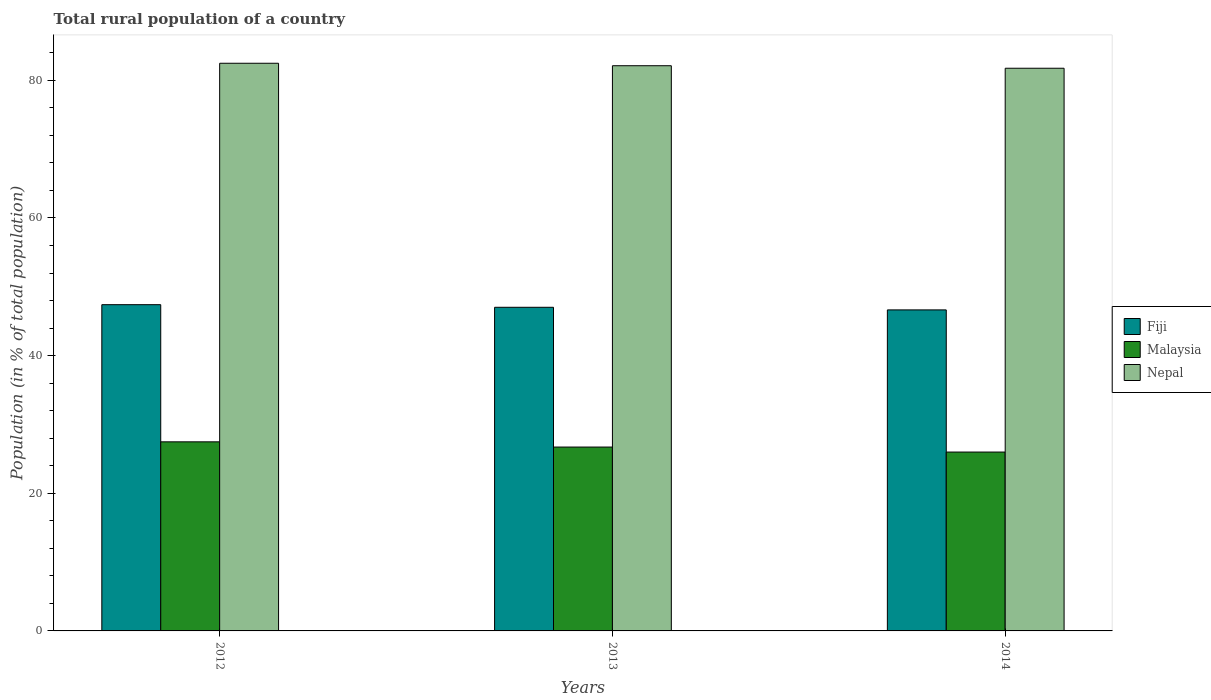How many different coloured bars are there?
Keep it short and to the point. 3. How many groups of bars are there?
Provide a short and direct response. 3. Are the number of bars per tick equal to the number of legend labels?
Your answer should be compact. Yes. How many bars are there on the 3rd tick from the left?
Offer a very short reply. 3. What is the label of the 3rd group of bars from the left?
Ensure brevity in your answer.  2014. What is the rural population in Malaysia in 2012?
Your answer should be compact. 27.47. Across all years, what is the maximum rural population in Nepal?
Offer a very short reply. 82.48. Across all years, what is the minimum rural population in Nepal?
Make the answer very short. 81.76. What is the total rural population in Nepal in the graph?
Ensure brevity in your answer.  246.36. What is the difference between the rural population in Fiji in 2012 and that in 2014?
Your answer should be very brief. 0.76. What is the difference between the rural population in Nepal in 2014 and the rural population in Malaysia in 2012?
Offer a terse response. 54.28. What is the average rural population in Nepal per year?
Give a very brief answer. 82.12. In the year 2012, what is the difference between the rural population in Malaysia and rural population in Fiji?
Offer a terse response. -19.93. In how many years, is the rural population in Malaysia greater than 60 %?
Your response must be concise. 0. What is the ratio of the rural population in Malaysia in 2012 to that in 2014?
Offer a very short reply. 1.06. Is the rural population in Nepal in 2012 less than that in 2014?
Offer a very short reply. No. Is the difference between the rural population in Malaysia in 2012 and 2013 greater than the difference between the rural population in Fiji in 2012 and 2013?
Your answer should be compact. Yes. What is the difference between the highest and the second highest rural population in Fiji?
Ensure brevity in your answer.  0.38. What is the difference between the highest and the lowest rural population in Fiji?
Ensure brevity in your answer.  0.76. What does the 3rd bar from the left in 2014 represents?
Provide a succinct answer. Nepal. What does the 1st bar from the right in 2012 represents?
Provide a short and direct response. Nepal. Is it the case that in every year, the sum of the rural population in Fiji and rural population in Malaysia is greater than the rural population in Nepal?
Your answer should be compact. No. How many bars are there?
Offer a very short reply. 9. How many years are there in the graph?
Make the answer very short. 3. What is the difference between two consecutive major ticks on the Y-axis?
Offer a terse response. 20. Does the graph contain any zero values?
Give a very brief answer. No. Where does the legend appear in the graph?
Your answer should be compact. Center right. What is the title of the graph?
Your response must be concise. Total rural population of a country. Does "Tuvalu" appear as one of the legend labels in the graph?
Your response must be concise. No. What is the label or title of the Y-axis?
Offer a terse response. Population (in % of total population). What is the Population (in % of total population) in Fiji in 2012?
Make the answer very short. 47.4. What is the Population (in % of total population) in Malaysia in 2012?
Your answer should be compact. 27.47. What is the Population (in % of total population) of Nepal in 2012?
Keep it short and to the point. 82.48. What is the Population (in % of total population) of Fiji in 2013?
Give a very brief answer. 47.02. What is the Population (in % of total population) of Malaysia in 2013?
Your answer should be very brief. 26.72. What is the Population (in % of total population) in Nepal in 2013?
Offer a very short reply. 82.12. What is the Population (in % of total population) of Fiji in 2014?
Your answer should be compact. 46.65. What is the Population (in % of total population) of Malaysia in 2014?
Your answer should be compact. 25.99. What is the Population (in % of total population) in Nepal in 2014?
Your response must be concise. 81.76. Across all years, what is the maximum Population (in % of total population) of Fiji?
Your answer should be very brief. 47.4. Across all years, what is the maximum Population (in % of total population) of Malaysia?
Offer a very short reply. 27.47. Across all years, what is the maximum Population (in % of total population) in Nepal?
Provide a succinct answer. 82.48. Across all years, what is the minimum Population (in % of total population) in Fiji?
Offer a very short reply. 46.65. Across all years, what is the minimum Population (in % of total population) of Malaysia?
Your response must be concise. 25.99. Across all years, what is the minimum Population (in % of total population) in Nepal?
Ensure brevity in your answer.  81.76. What is the total Population (in % of total population) of Fiji in the graph?
Provide a succinct answer. 141.07. What is the total Population (in % of total population) of Malaysia in the graph?
Provide a short and direct response. 80.18. What is the total Population (in % of total population) in Nepal in the graph?
Ensure brevity in your answer.  246.36. What is the difference between the Population (in % of total population) in Fiji in 2012 and that in 2013?
Your response must be concise. 0.38. What is the difference between the Population (in % of total population) of Malaysia in 2012 and that in 2013?
Offer a very short reply. 0.76. What is the difference between the Population (in % of total population) of Nepal in 2012 and that in 2013?
Offer a very short reply. 0.36. What is the difference between the Population (in % of total population) in Fiji in 2012 and that in 2014?
Offer a very short reply. 0.76. What is the difference between the Population (in % of total population) in Malaysia in 2012 and that in 2014?
Offer a very short reply. 1.48. What is the difference between the Population (in % of total population) of Nepal in 2012 and that in 2014?
Give a very brief answer. 0.72. What is the difference between the Population (in % of total population) of Fiji in 2013 and that in 2014?
Provide a short and direct response. 0.38. What is the difference between the Population (in % of total population) of Malaysia in 2013 and that in 2014?
Your response must be concise. 0.73. What is the difference between the Population (in % of total population) in Nepal in 2013 and that in 2014?
Provide a short and direct response. 0.37. What is the difference between the Population (in % of total population) in Fiji in 2012 and the Population (in % of total population) in Malaysia in 2013?
Your answer should be compact. 20.69. What is the difference between the Population (in % of total population) of Fiji in 2012 and the Population (in % of total population) of Nepal in 2013?
Provide a succinct answer. -34.72. What is the difference between the Population (in % of total population) of Malaysia in 2012 and the Population (in % of total population) of Nepal in 2013?
Your answer should be compact. -54.65. What is the difference between the Population (in % of total population) in Fiji in 2012 and the Population (in % of total population) in Malaysia in 2014?
Make the answer very short. 21.41. What is the difference between the Population (in % of total population) of Fiji in 2012 and the Population (in % of total population) of Nepal in 2014?
Your response must be concise. -34.35. What is the difference between the Population (in % of total population) in Malaysia in 2012 and the Population (in % of total population) in Nepal in 2014?
Keep it short and to the point. -54.28. What is the difference between the Population (in % of total population) of Fiji in 2013 and the Population (in % of total population) of Malaysia in 2014?
Offer a terse response. 21.03. What is the difference between the Population (in % of total population) of Fiji in 2013 and the Population (in % of total population) of Nepal in 2014?
Ensure brevity in your answer.  -34.73. What is the difference between the Population (in % of total population) in Malaysia in 2013 and the Population (in % of total population) in Nepal in 2014?
Make the answer very short. -55.04. What is the average Population (in % of total population) of Fiji per year?
Offer a very short reply. 47.02. What is the average Population (in % of total population) of Malaysia per year?
Your response must be concise. 26.73. What is the average Population (in % of total population) of Nepal per year?
Your answer should be compact. 82.12. In the year 2012, what is the difference between the Population (in % of total population) of Fiji and Population (in % of total population) of Malaysia?
Your response must be concise. 19.93. In the year 2012, what is the difference between the Population (in % of total population) in Fiji and Population (in % of total population) in Nepal?
Offer a very short reply. -35.08. In the year 2012, what is the difference between the Population (in % of total population) in Malaysia and Population (in % of total population) in Nepal?
Your response must be concise. -55.01. In the year 2013, what is the difference between the Population (in % of total population) of Fiji and Population (in % of total population) of Malaysia?
Offer a terse response. 20.31. In the year 2013, what is the difference between the Population (in % of total population) of Fiji and Population (in % of total population) of Nepal?
Provide a short and direct response. -35.1. In the year 2013, what is the difference between the Population (in % of total population) of Malaysia and Population (in % of total population) of Nepal?
Provide a succinct answer. -55.41. In the year 2014, what is the difference between the Population (in % of total population) in Fiji and Population (in % of total population) in Malaysia?
Give a very brief answer. 20.66. In the year 2014, what is the difference between the Population (in % of total population) of Fiji and Population (in % of total population) of Nepal?
Provide a succinct answer. -35.11. In the year 2014, what is the difference between the Population (in % of total population) of Malaysia and Population (in % of total population) of Nepal?
Keep it short and to the point. -55.77. What is the ratio of the Population (in % of total population) of Malaysia in 2012 to that in 2013?
Provide a succinct answer. 1.03. What is the ratio of the Population (in % of total population) of Nepal in 2012 to that in 2013?
Your response must be concise. 1. What is the ratio of the Population (in % of total population) in Fiji in 2012 to that in 2014?
Provide a succinct answer. 1.02. What is the ratio of the Population (in % of total population) of Malaysia in 2012 to that in 2014?
Offer a very short reply. 1.06. What is the ratio of the Population (in % of total population) of Nepal in 2012 to that in 2014?
Offer a terse response. 1.01. What is the ratio of the Population (in % of total population) in Fiji in 2013 to that in 2014?
Give a very brief answer. 1.01. What is the ratio of the Population (in % of total population) of Malaysia in 2013 to that in 2014?
Offer a very short reply. 1.03. What is the difference between the highest and the second highest Population (in % of total population) in Fiji?
Offer a terse response. 0.38. What is the difference between the highest and the second highest Population (in % of total population) of Malaysia?
Make the answer very short. 0.76. What is the difference between the highest and the second highest Population (in % of total population) of Nepal?
Provide a succinct answer. 0.36. What is the difference between the highest and the lowest Population (in % of total population) in Fiji?
Your answer should be compact. 0.76. What is the difference between the highest and the lowest Population (in % of total population) in Malaysia?
Your answer should be compact. 1.48. What is the difference between the highest and the lowest Population (in % of total population) of Nepal?
Keep it short and to the point. 0.72. 